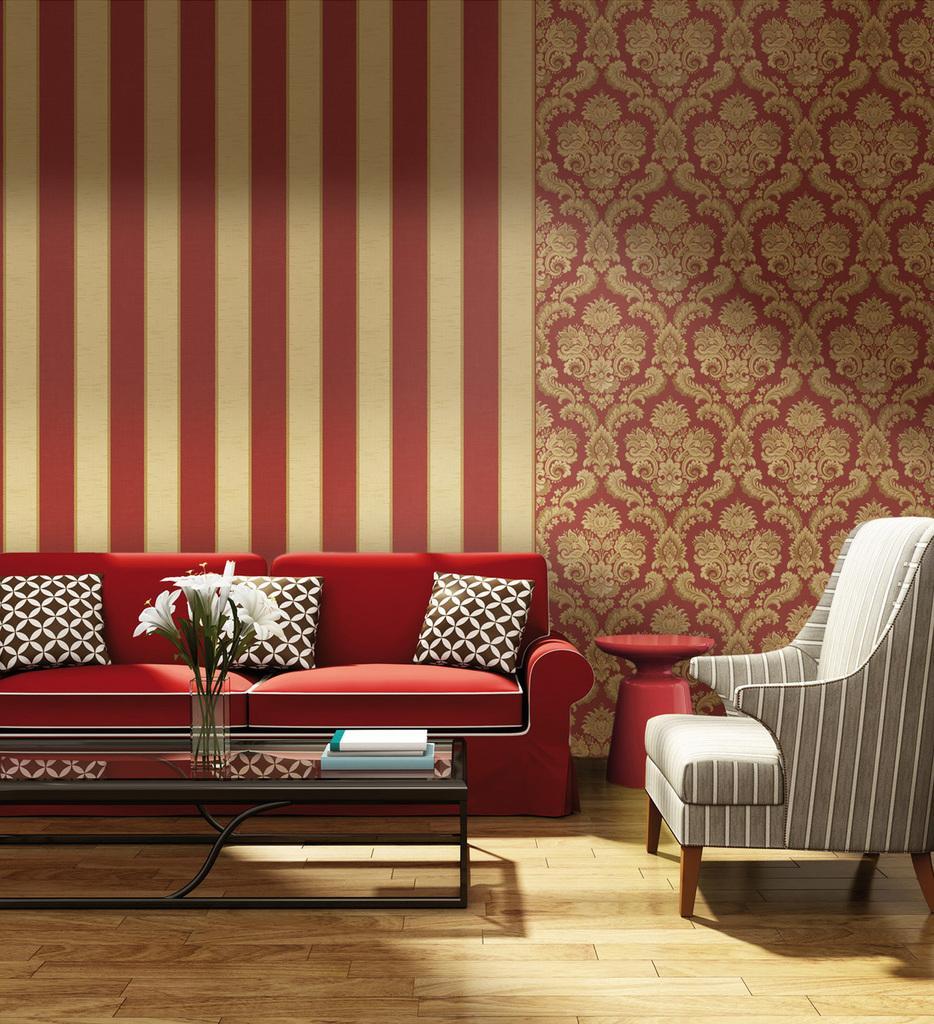Can you describe this image briefly? There is a red sofa which has three pillows on it and there is a sofa beside it and there is a table in front of it and the background wall is red in color. 